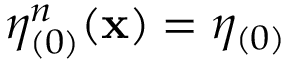<formula> <loc_0><loc_0><loc_500><loc_500>\eta _ { ( 0 ) } ^ { n } ( x ) = \eta _ { ( 0 ) }</formula> 